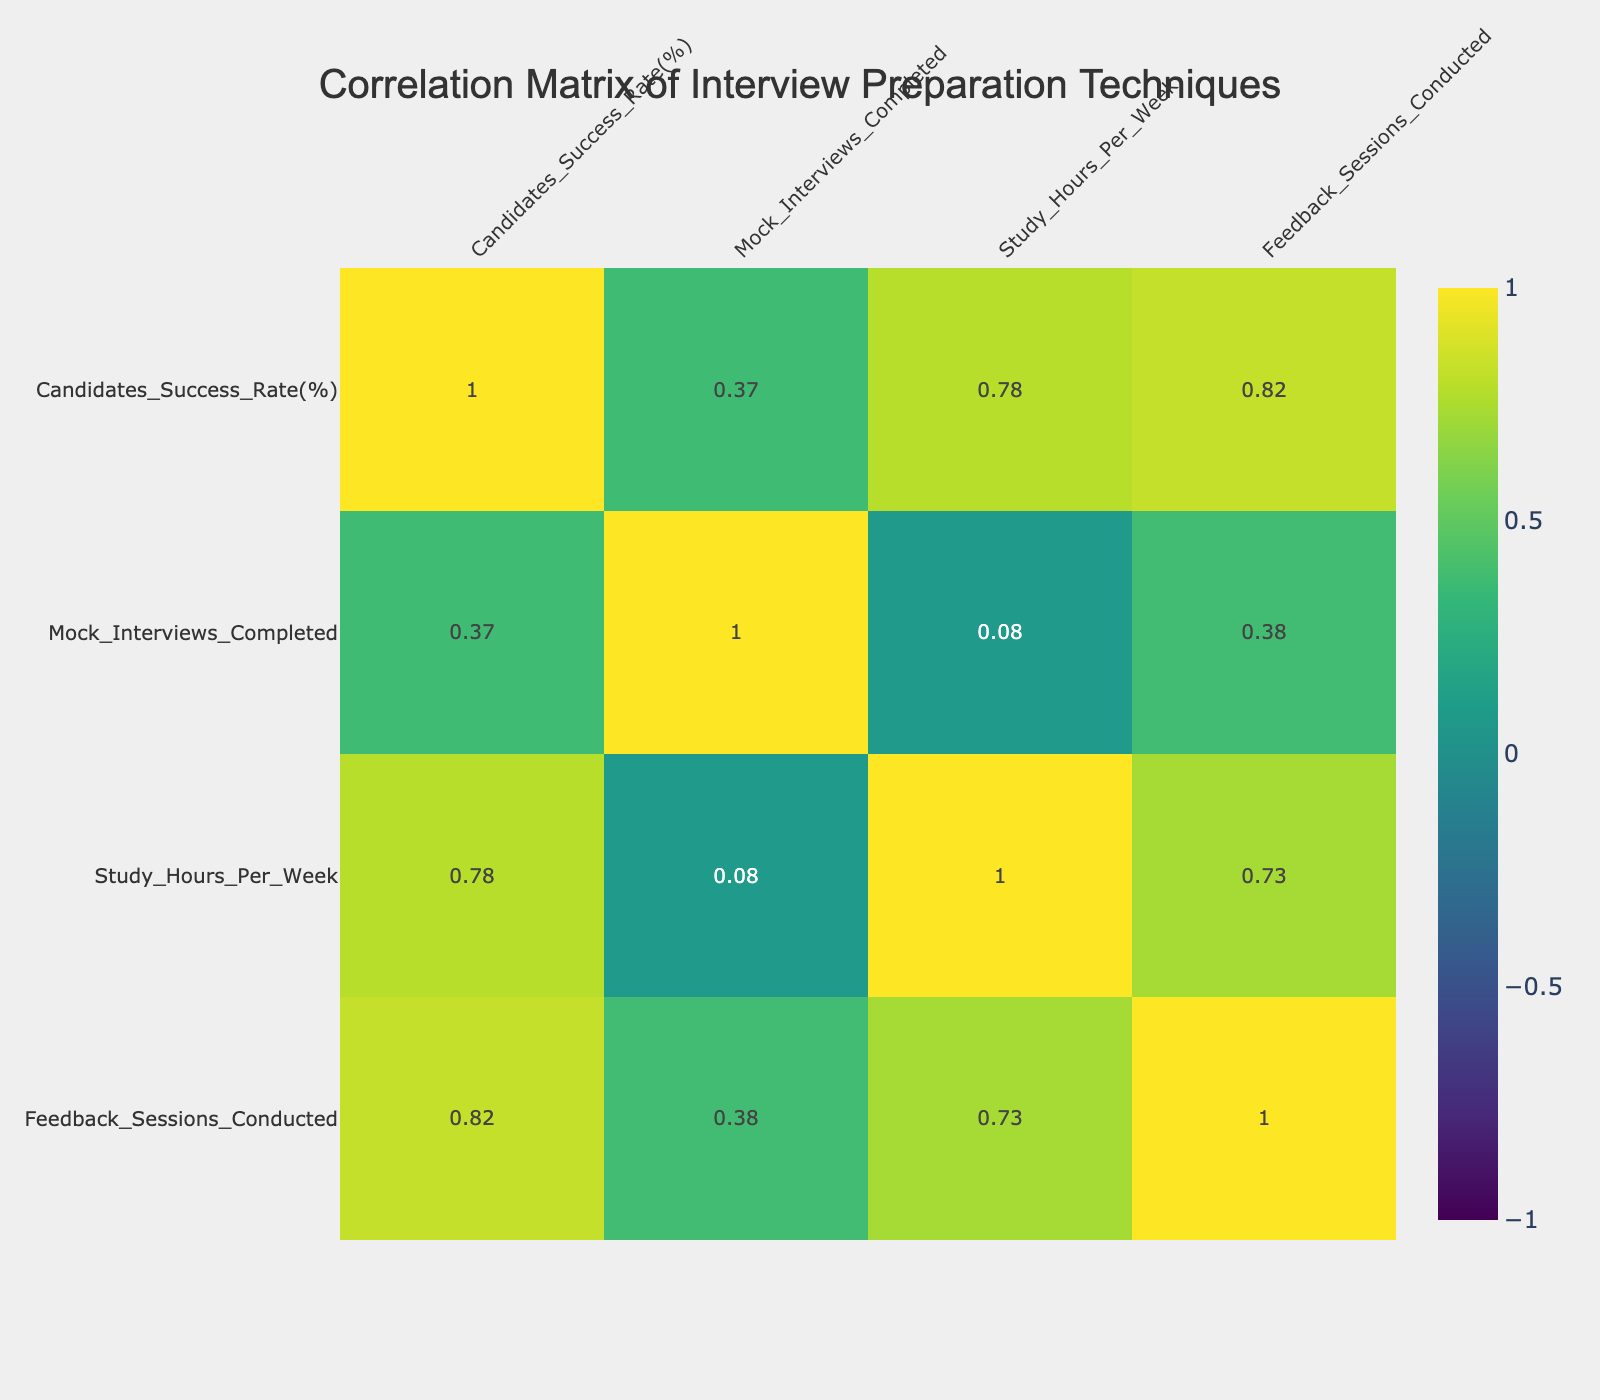What is the candidates' success rate for Professional Coaching? The candidates' success rate for Professional Coaching is located in the second column of the table under the row for Professional Coaching, which shows a value of 90%.
Answer: 90% Which interview preparation technique has the highest success rate? To find the highest success rate, I look through the second column; Professional Coaching has the highest value at 90%.
Answer: Professional Coaching What is the average success rate of all the preparation techniques? I need to calculate the average by adding all the success rates: (78 + 85 + 65 + 80 + 90 + 75 + 88 + 82) = 78.75. Then, divide this sum by the total number of techniques, which is 8. So, 78.75/8 = 78.75.
Answer: 78.75 Is the success rate of Mock Interviews correlated positively with Study Hours per Week? To find correlation, I look at the correlation value between the columns for Mock Interviews Completed and Study Hours Per Week. A positive correlation means both values increase together. Here's the correlation: 0.12, which indicates a slight positive correlation.
Answer: Yes What is the lowest number of Mock Interviews completed among all preparation techniques, and which technique does it relate to? I check the Mock Interviews Completed column for the lowest value, which is 2 for Self-Study.
Answer: Self-Study, 2 How does the success rate change from Self-Study to Professional Coaching? The success rate for Self-Study is 65% and for Professional Coaching is 90%. The change can be calculated as 90 - 65 = 25. This indicates that Professional Coaching has a 25% higher success rate compared to Self-Study.
Answer: 25% increase Which preparation technique has the most Mock Interviews completed and what is the success rate for that technique? By reviewing the Mock Interviews Completed column, Peer Review Practice has the highest number at 6. Its success rate, according to the corresponding row, is 80%.
Answer: 6 Mock Interviews, 80% success rate Is there a technique that has both a high success rate and a relatively higher number of Feedback Sessions Conducted compared to others? I look for high success rates above 85% and see that Professional Coaching (90% with 5 feedback sessions) and Behavioral Interview Training (88% with 3 feedback sessions) fit this criterion, but Professional Coaching stands out with the most feedback sessions as well.
Answer: Yes, Professional Coaching 